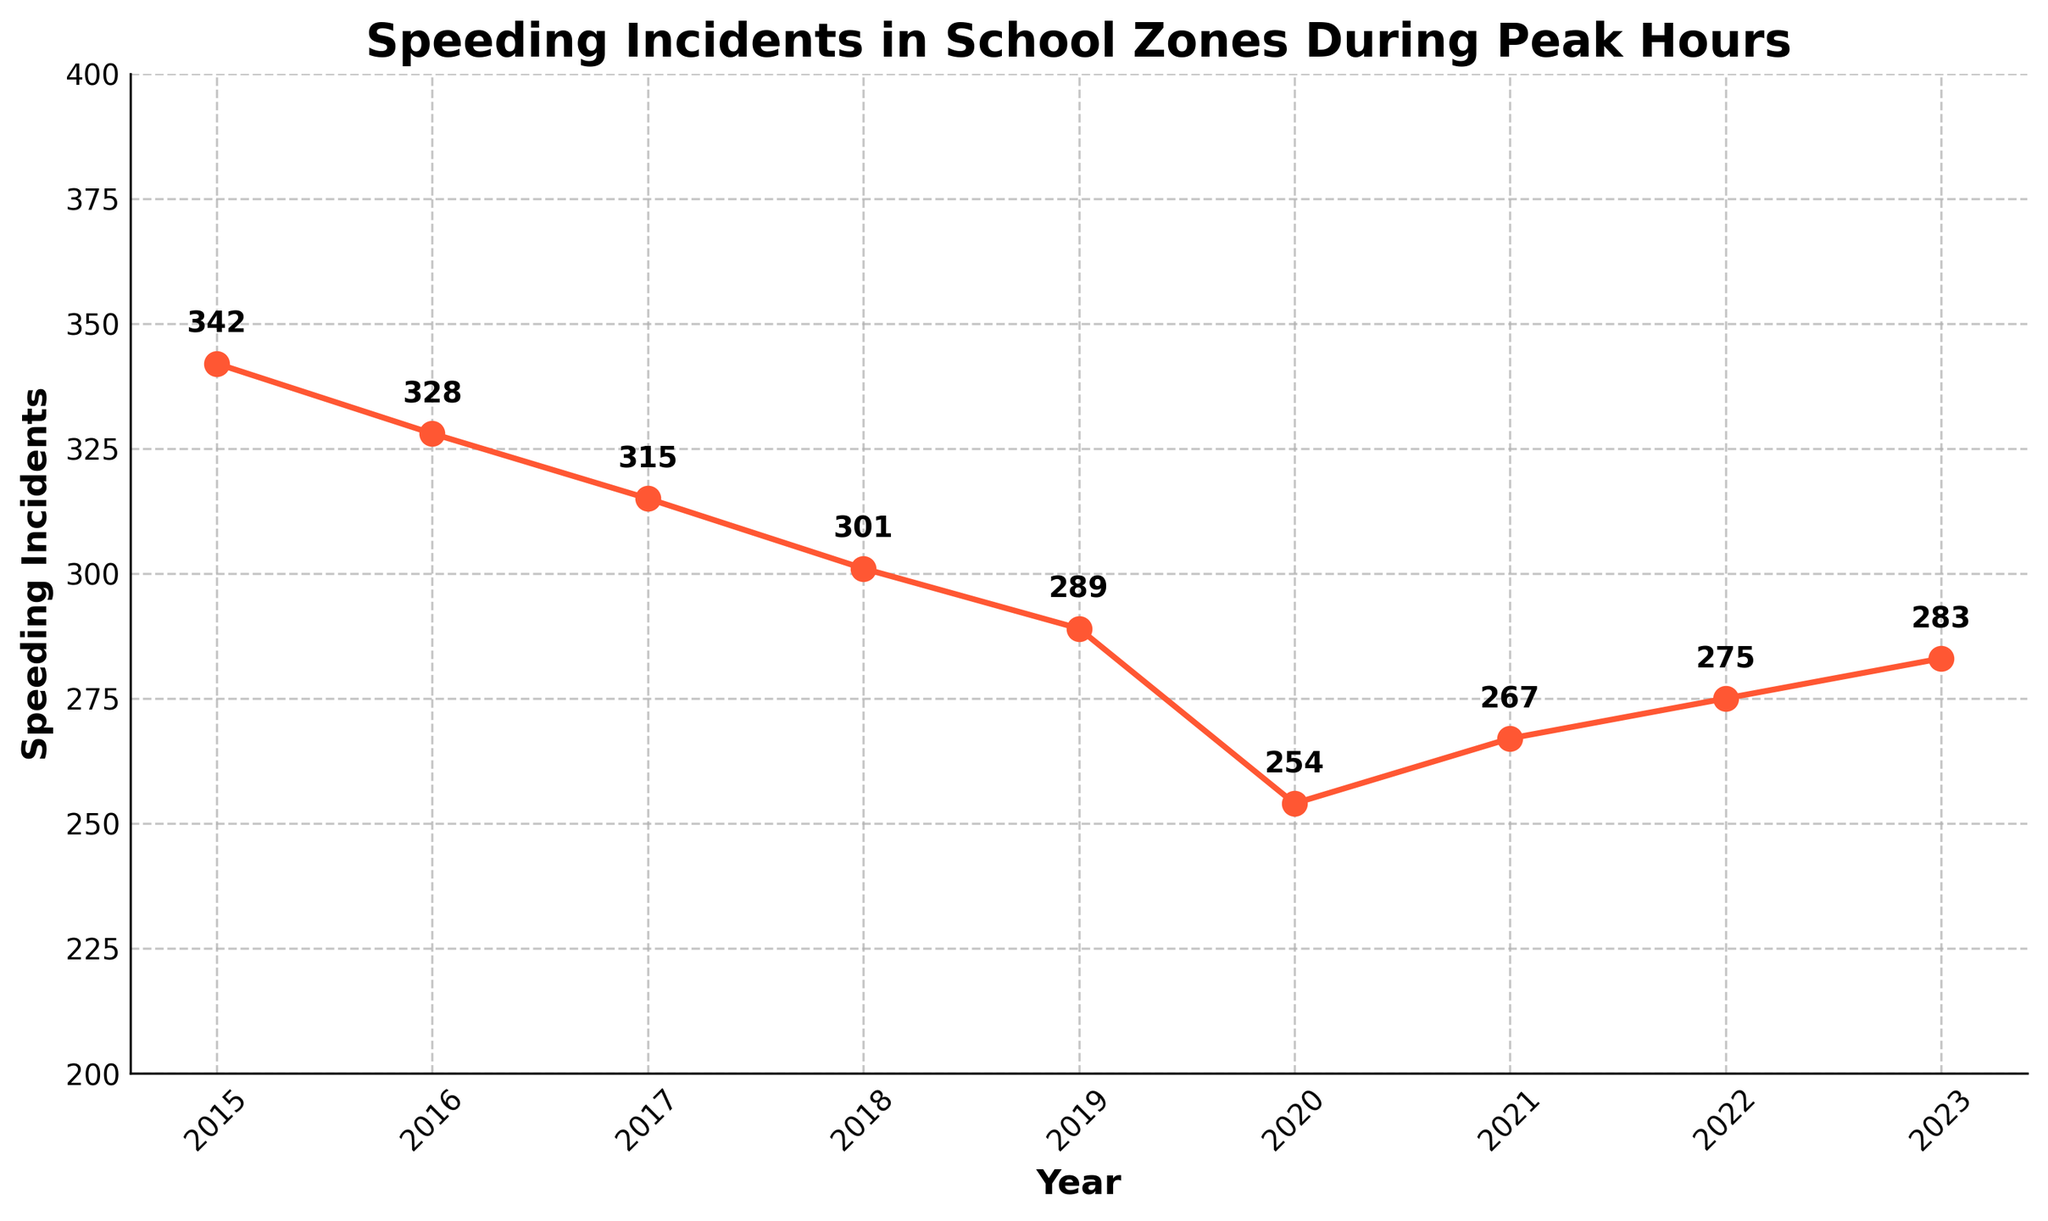What year had the highest number of speeding incidents? Look at the plot and identify the highest point on the line graph. The year corresponding to this point indicates the highest number of incidents.
Answer: 2015 Which year had the lowest number of speeding incidents? Find the lowest point on the line graph and identify the corresponding year.
Answer: 2020 How much did the number of speeding incidents decrease from 2015 to 2020? Subtract the number of speeding incidents in 2020 from the number in 2015: 342 - 254 = 88
Answer: 88 What is the overall trend in speeding incidents from 2015 to 2023? Observe the general direction of the line from 2015 to 2023. The line generally trends downward, indicating a decrease in incidents over the period.
Answer: Decreasing Did the number of speeding incidents increase or decrease from 2020 to 2021? Compare the values for 2020 and 2021 on the plot. The number increased from 254 to 267.
Answer: Increase What is the average number of speeding incidents per year from 2015 to 2023? Add the yearly numbers and divide by 9: (342 + 328 + 315 + 301 + 289 + 254 + 267 + 275 + 283) / 9 ≈ 295.8
Answer: 295.8 How did the number of speeding incidents change between 2019 and 2021? Subtract the number of incidents in 2019 from the number in 2021: 267 - 289 = -22, so there is a decrease of 22 incidents.
Answer: Decrease of 22 What is the difference in speeding incidents between the year with the highest incidents and the year with the lowest incidents? Subtract the number of incidents in the year with the lowest incidents (2020) from the year with the highest (2015): 342 - 254 = 88
Answer: 88 What is the visual color of the line denoting speeding incidents on the plot? The line on the plot is colored, and we identify it as red by examining the chart.
Answer: Red 